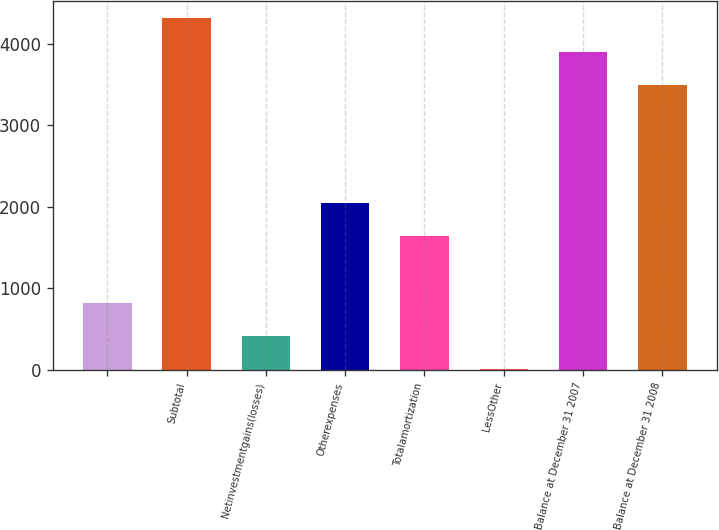<chart> <loc_0><loc_0><loc_500><loc_500><bar_chart><ecel><fcel>Subtotal<fcel>Netinvestmentgains(losses)<fcel>Otherexpenses<fcel>Totalamortization<fcel>LessOther<fcel>Balance at December 31 2007<fcel>Balance at December 31 2008<nl><fcel>822.4<fcel>4308.4<fcel>413.7<fcel>2048.5<fcel>1639.8<fcel>5<fcel>3899.7<fcel>3491<nl></chart> 